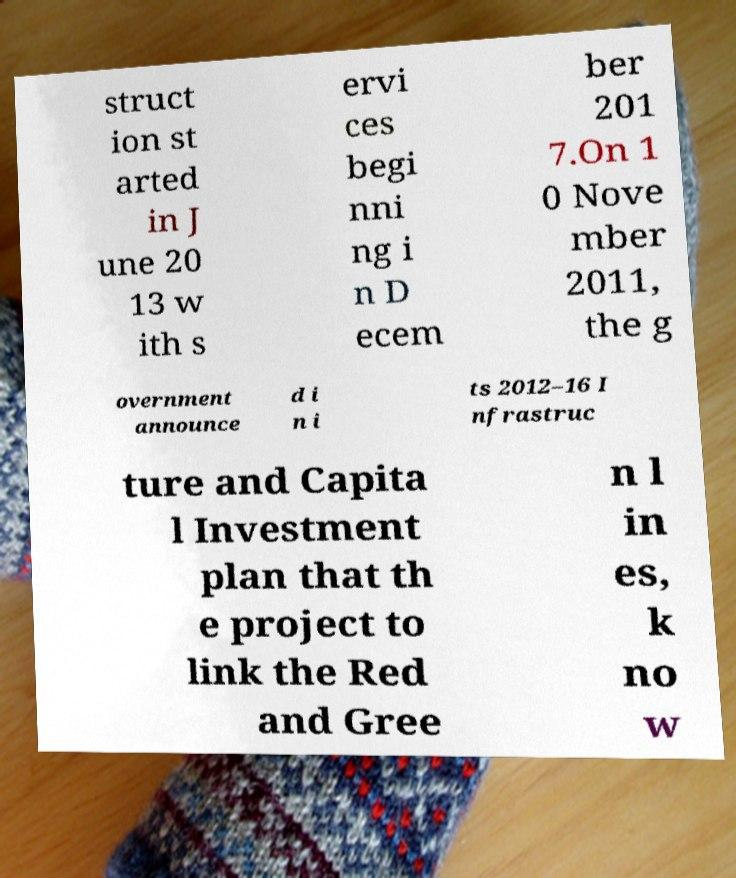Could you assist in decoding the text presented in this image and type it out clearly? struct ion st arted in J une 20 13 w ith s ervi ces begi nni ng i n D ecem ber 201 7.On 1 0 Nove mber 2011, the g overnment announce d i n i ts 2012–16 I nfrastruc ture and Capita l Investment plan that th e project to link the Red and Gree n l in es, k no w 